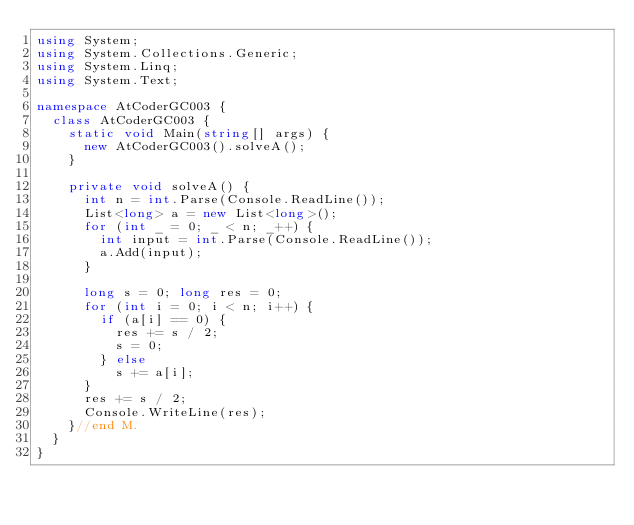Convert code to text. <code><loc_0><loc_0><loc_500><loc_500><_C#_>using System;
using System.Collections.Generic;
using System.Linq;
using System.Text;

namespace AtCoderGC003 {
  class AtCoderGC003 {
    static void Main(string[] args) {
      new AtCoderGC003().solveA();
    }

    private void solveA() {
      int n = int.Parse(Console.ReadLine());
      List<long> a = new List<long>();
      for (int _ = 0; _ < n; _++) {
        int input = int.Parse(Console.ReadLine());
        a.Add(input);
      }

      long s = 0; long res = 0;
      for (int i = 0; i < n; i++) {
        if (a[i] == 0) {
          res += s / 2;
          s = 0;
        } else 
          s += a[i];
      }
      res += s / 2;
      Console.WriteLine(res);
    }//end M.
  }
}
</code> 